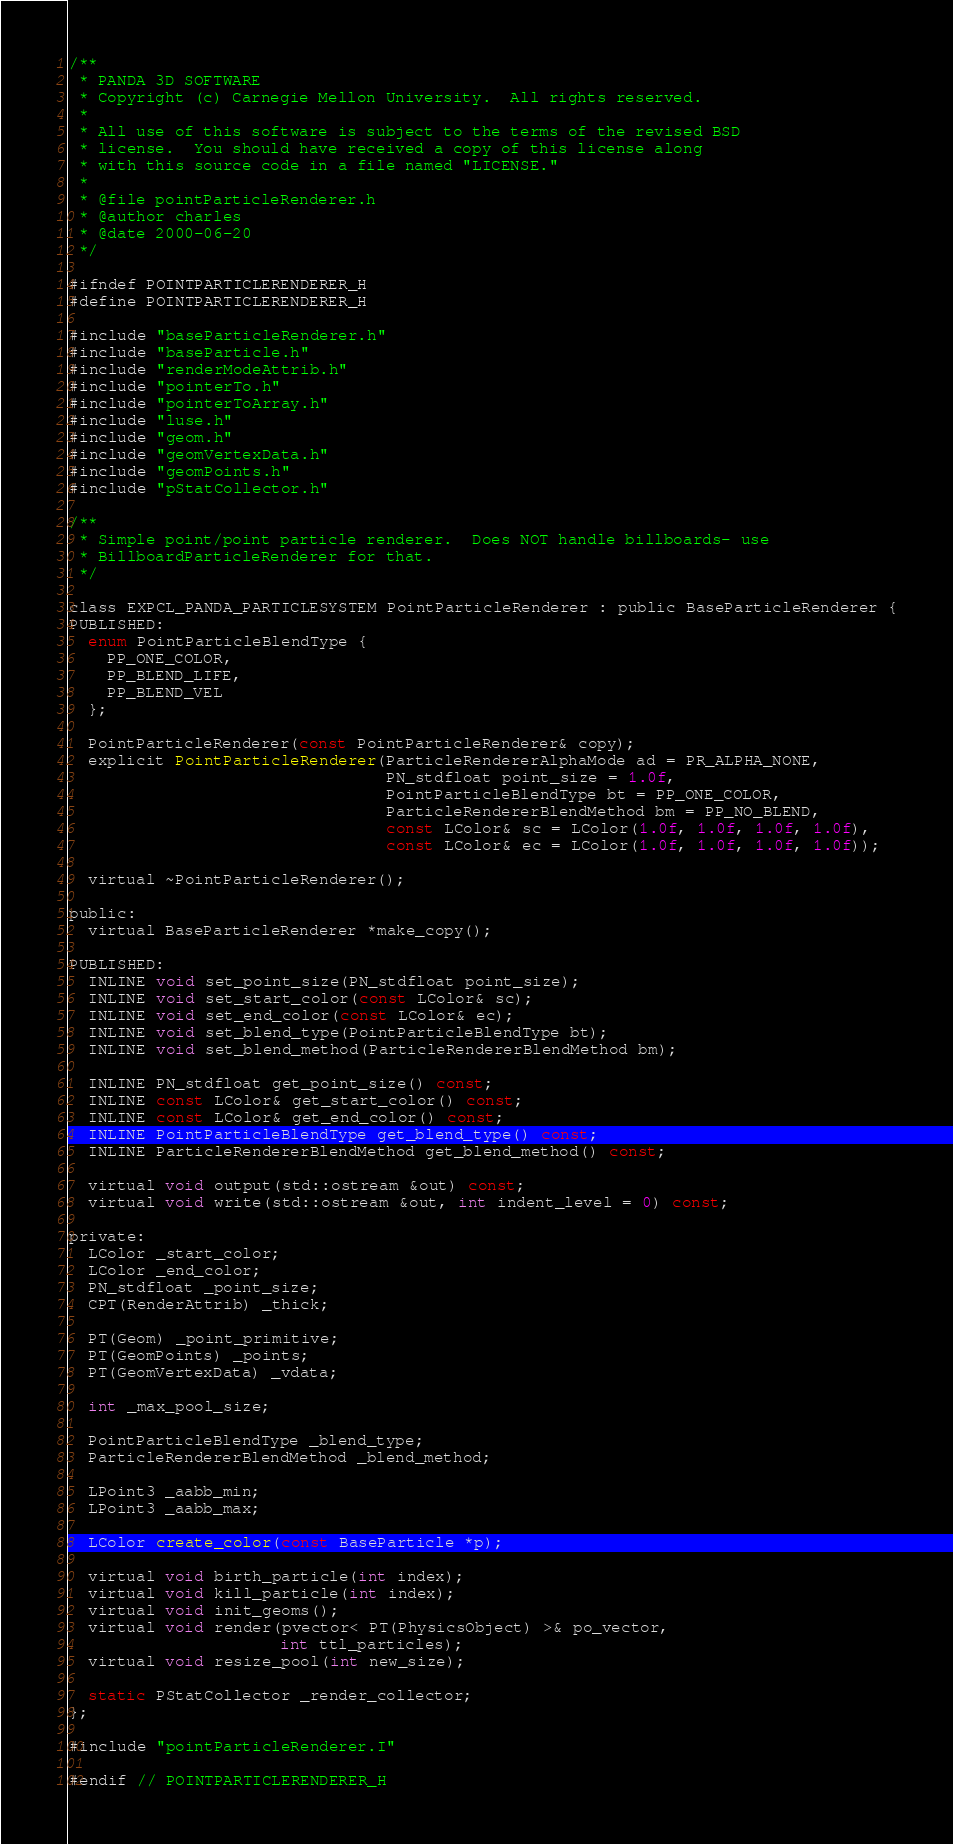<code> <loc_0><loc_0><loc_500><loc_500><_C_>/**
 * PANDA 3D SOFTWARE
 * Copyright (c) Carnegie Mellon University.  All rights reserved.
 *
 * All use of this software is subject to the terms of the revised BSD
 * license.  You should have received a copy of this license along
 * with this source code in a file named "LICENSE."
 *
 * @file pointParticleRenderer.h
 * @author charles
 * @date 2000-06-20
 */

#ifndef POINTPARTICLERENDERER_H
#define POINTPARTICLERENDERER_H

#include "baseParticleRenderer.h"
#include "baseParticle.h"
#include "renderModeAttrib.h"
#include "pointerTo.h"
#include "pointerToArray.h"
#include "luse.h"
#include "geom.h"
#include "geomVertexData.h"
#include "geomPoints.h"
#include "pStatCollector.h"

/**
 * Simple point/point particle renderer.  Does NOT handle billboards- use
 * BillboardParticleRenderer for that.
 */

class EXPCL_PANDA_PARTICLESYSTEM PointParticleRenderer : public BaseParticleRenderer {
PUBLISHED:
  enum PointParticleBlendType {
    PP_ONE_COLOR,
    PP_BLEND_LIFE,
    PP_BLEND_VEL
  };

  PointParticleRenderer(const PointParticleRenderer& copy);
  explicit PointParticleRenderer(ParticleRendererAlphaMode ad = PR_ALPHA_NONE,
                                 PN_stdfloat point_size = 1.0f,
                                 PointParticleBlendType bt = PP_ONE_COLOR,
                                 ParticleRendererBlendMethod bm = PP_NO_BLEND,
                                 const LColor& sc = LColor(1.0f, 1.0f, 1.0f, 1.0f),
                                 const LColor& ec = LColor(1.0f, 1.0f, 1.0f, 1.0f));

  virtual ~PointParticleRenderer();

public:
  virtual BaseParticleRenderer *make_copy();

PUBLISHED:
  INLINE void set_point_size(PN_stdfloat point_size);
  INLINE void set_start_color(const LColor& sc);
  INLINE void set_end_color(const LColor& ec);
  INLINE void set_blend_type(PointParticleBlendType bt);
  INLINE void set_blend_method(ParticleRendererBlendMethod bm);

  INLINE PN_stdfloat get_point_size() const;
  INLINE const LColor& get_start_color() const;
  INLINE const LColor& get_end_color() const;
  INLINE PointParticleBlendType get_blend_type() const;
  INLINE ParticleRendererBlendMethod get_blend_method() const;

  virtual void output(std::ostream &out) const;
  virtual void write(std::ostream &out, int indent_level = 0) const;

private:
  LColor _start_color;
  LColor _end_color;
  PN_stdfloat _point_size;
  CPT(RenderAttrib) _thick;

  PT(Geom) _point_primitive;
  PT(GeomPoints) _points;
  PT(GeomVertexData) _vdata;

  int _max_pool_size;

  PointParticleBlendType _blend_type;
  ParticleRendererBlendMethod _blend_method;

  LPoint3 _aabb_min;
  LPoint3 _aabb_max;

  LColor create_color(const BaseParticle *p);

  virtual void birth_particle(int index);
  virtual void kill_particle(int index);
  virtual void init_geoms();
  virtual void render(pvector< PT(PhysicsObject) >& po_vector,
                      int ttl_particles);
  virtual void resize_pool(int new_size);

  static PStatCollector _render_collector;
};

#include "pointParticleRenderer.I"

#endif // POINTPARTICLERENDERER_H
</code> 